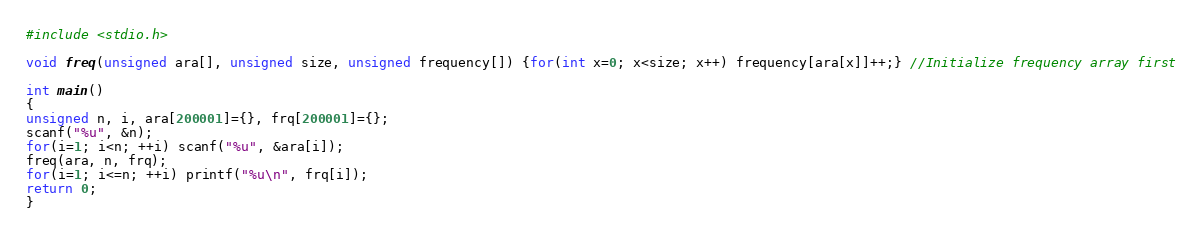Convert code to text. <code><loc_0><loc_0><loc_500><loc_500><_C_>#include <stdio.h>

void freq(unsigned ara[], unsigned size, unsigned frequency[]) {for(int x=0; x<size; x++) frequency[ara[x]]++;} //Initialize frequency array first

int main()
{
unsigned n, i, ara[200001]={}, frq[200001]={};
scanf("%u", &n);
for(i=1; i<n; ++i) scanf("%u", &ara[i]);
freq(ara, n, frq);
for(i=1; i<=n; ++i) printf("%u\n", frq[i]);
return 0;
}
</code> 